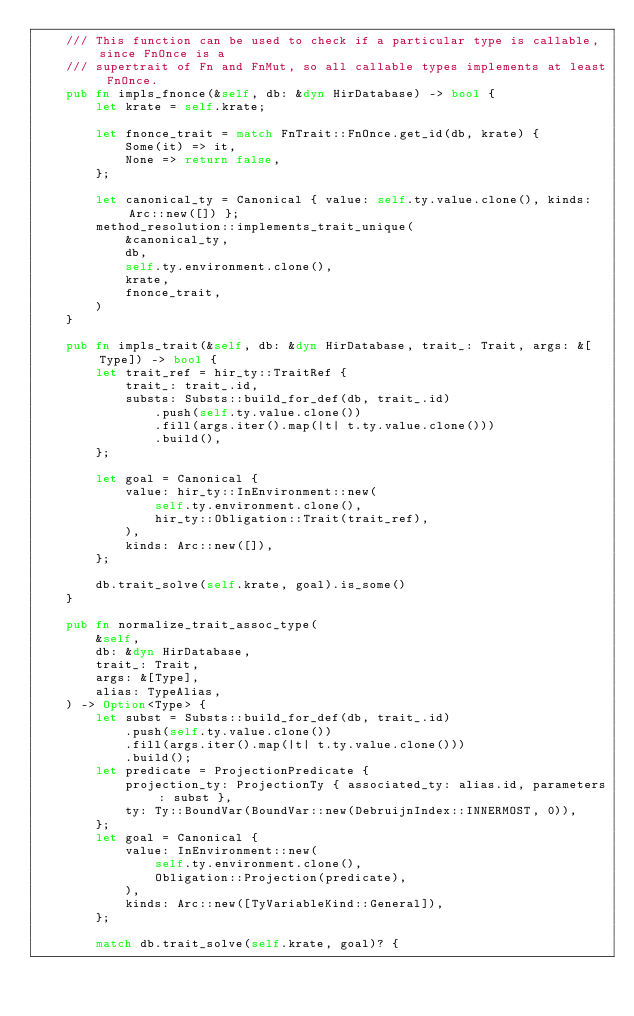Convert code to text. <code><loc_0><loc_0><loc_500><loc_500><_Rust_>    /// This function can be used to check if a particular type is callable, since FnOnce is a
    /// supertrait of Fn and FnMut, so all callable types implements at least FnOnce.
    pub fn impls_fnonce(&self, db: &dyn HirDatabase) -> bool {
        let krate = self.krate;

        let fnonce_trait = match FnTrait::FnOnce.get_id(db, krate) {
            Some(it) => it,
            None => return false,
        };

        let canonical_ty = Canonical { value: self.ty.value.clone(), kinds: Arc::new([]) };
        method_resolution::implements_trait_unique(
            &canonical_ty,
            db,
            self.ty.environment.clone(),
            krate,
            fnonce_trait,
        )
    }

    pub fn impls_trait(&self, db: &dyn HirDatabase, trait_: Trait, args: &[Type]) -> bool {
        let trait_ref = hir_ty::TraitRef {
            trait_: trait_.id,
            substs: Substs::build_for_def(db, trait_.id)
                .push(self.ty.value.clone())
                .fill(args.iter().map(|t| t.ty.value.clone()))
                .build(),
        };

        let goal = Canonical {
            value: hir_ty::InEnvironment::new(
                self.ty.environment.clone(),
                hir_ty::Obligation::Trait(trait_ref),
            ),
            kinds: Arc::new([]),
        };

        db.trait_solve(self.krate, goal).is_some()
    }

    pub fn normalize_trait_assoc_type(
        &self,
        db: &dyn HirDatabase,
        trait_: Trait,
        args: &[Type],
        alias: TypeAlias,
    ) -> Option<Type> {
        let subst = Substs::build_for_def(db, trait_.id)
            .push(self.ty.value.clone())
            .fill(args.iter().map(|t| t.ty.value.clone()))
            .build();
        let predicate = ProjectionPredicate {
            projection_ty: ProjectionTy { associated_ty: alias.id, parameters: subst },
            ty: Ty::BoundVar(BoundVar::new(DebruijnIndex::INNERMOST, 0)),
        };
        let goal = Canonical {
            value: InEnvironment::new(
                self.ty.environment.clone(),
                Obligation::Projection(predicate),
            ),
            kinds: Arc::new([TyVariableKind::General]),
        };

        match db.trait_solve(self.krate, goal)? {</code> 